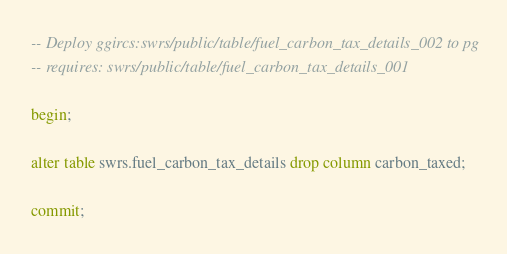<code> <loc_0><loc_0><loc_500><loc_500><_SQL_>-- Deploy ggircs:swrs/public/table/fuel_carbon_tax_details_002 to pg
-- requires: swrs/public/table/fuel_carbon_tax_details_001

begin;

alter table swrs.fuel_carbon_tax_details drop column carbon_taxed;

commit;
</code> 